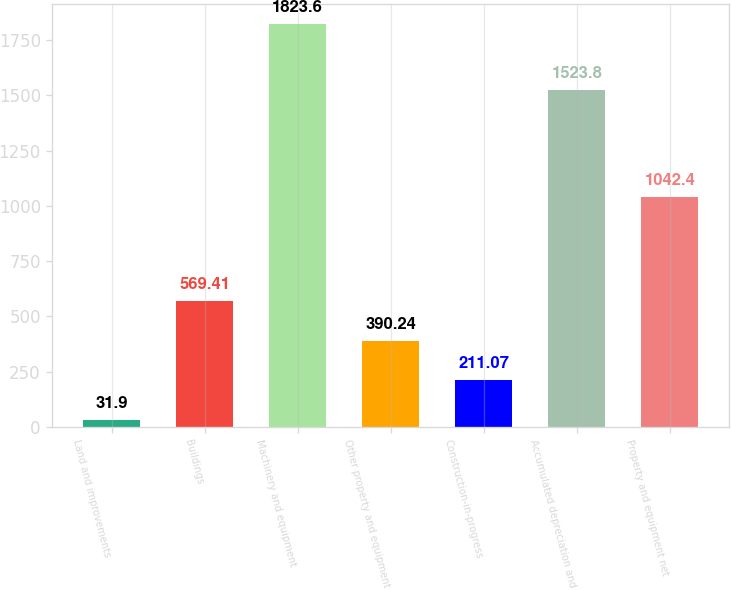<chart> <loc_0><loc_0><loc_500><loc_500><bar_chart><fcel>Land and improvements<fcel>Buildings<fcel>Machinery and equipment<fcel>Other property and equipment<fcel>Construction-in-progress<fcel>Accumulated depreciation and<fcel>Property and equipment net<nl><fcel>31.9<fcel>569.41<fcel>1823.6<fcel>390.24<fcel>211.07<fcel>1523.8<fcel>1042.4<nl></chart> 